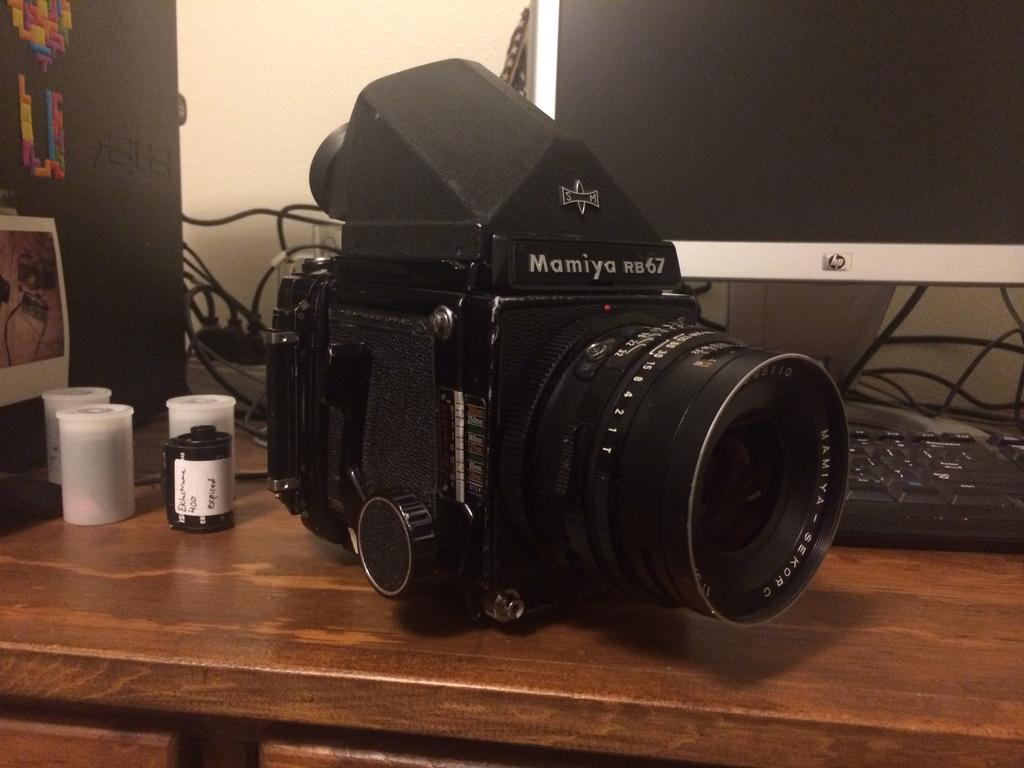What color is the wall in the image? The wall in the image is white. What can be seen on the wall? There is a screen on the wall. What furniture is present in the image? There is a table in the image. What items are on the table? There is a keyboard, a camera, a switchboard, and lights on the table. What type of decorations are present in the image? There are photo frames in the image. What is the value of the government in the image? There is no reference to a government or its value in the image. The image primarily features a table with various electronic devices and photo frames on a white wall. 